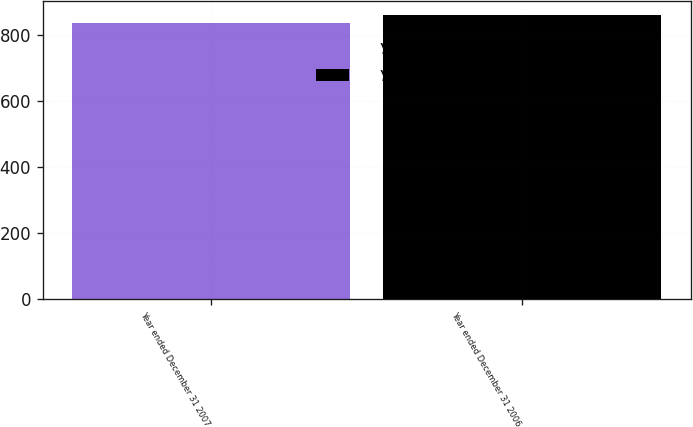<chart> <loc_0><loc_0><loc_500><loc_500><bar_chart><fcel>Year ended December 31 2007<fcel>Year ended December 31 2006<nl><fcel>837<fcel>861<nl></chart> 